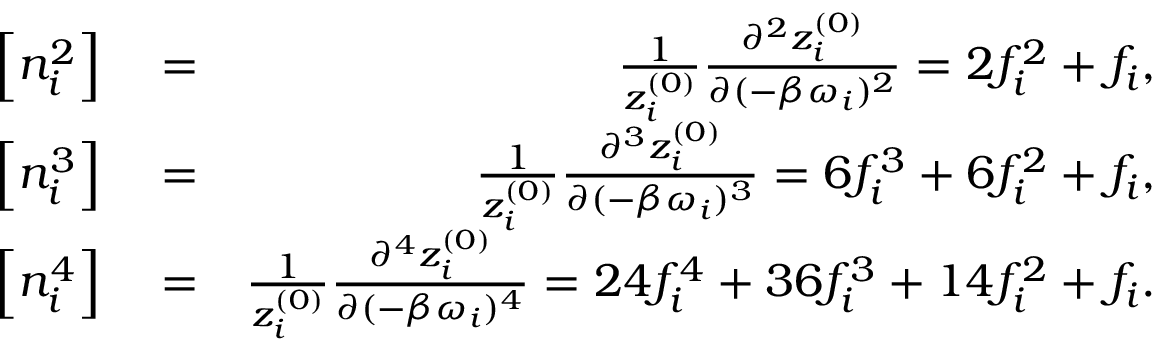<formula> <loc_0><loc_0><loc_500><loc_500>\begin{array} { r l r } { \left [ n _ { i } ^ { 2 } \right ] } & = } & { \frac { 1 } { z _ { i } ^ { ( 0 ) } } \frac { \partial ^ { 2 } z _ { i } ^ { ( 0 ) } } { \partial ( - \beta \omega _ { i } ) ^ { 2 } } = 2 f _ { i } ^ { 2 } + f _ { i } , } \\ { \left [ { n _ { i } ^ { 3 } } \right ] } & = } & { \frac { 1 } { z _ { i } ^ { ( 0 ) } } \frac { \partial ^ { 3 } z _ { i } ^ { ( 0 ) } } { \partial ( - \beta \omega _ { i } ) ^ { 3 } } = 6 f _ { i } ^ { 3 } + 6 f _ { i } ^ { 2 } + f _ { i } , } \\ { \left [ { n _ { i } ^ { 4 } } \right ] } & = } & { \frac { 1 } { z _ { i } ^ { ( 0 ) } } \frac { \partial ^ { 4 } z _ { i } ^ { ( 0 ) } } { \partial ( - \beta \omega _ { i } ) ^ { 4 } } = 2 4 f _ { i } ^ { 4 } + 3 6 f _ { i } ^ { 3 } + 1 4 f _ { i } ^ { 2 } + f _ { i } . } \end{array}</formula> 